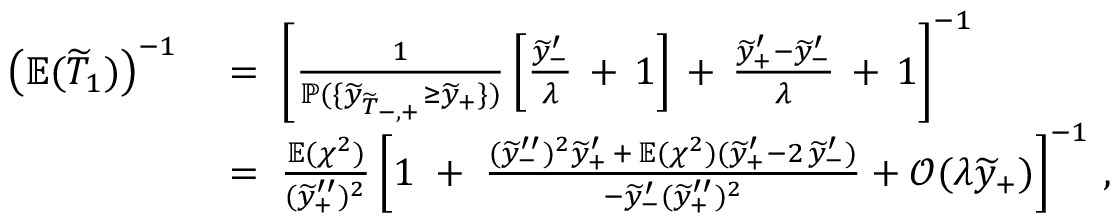<formula> <loc_0><loc_0><loc_500><loc_500>\begin{array} { r l } { \left ( \mathbb { E } ( \widetilde { T } _ { 1 } ) \right ) ^ { - 1 } } & { \, = \, \left [ \frac { 1 } { \mathbb { P } ( \{ \widetilde { y } _ { \widetilde { T } _ { - , + } } \geq \widetilde { y } _ { + } \} ) } \left [ \frac { \widetilde { y } _ { - } ^ { \prime } } { \lambda } \, + \, 1 \right ] \, + \, \frac { \widetilde { y } _ { + } ^ { \prime } - \widetilde { y } _ { - } ^ { \prime } } { \lambda } \, + \, 1 \right ] ^ { - 1 } } \\ & { \, = \, \frac { \mathbb { E } ( \chi ^ { 2 } ) } { ( \widetilde { y } _ { + } ^ { \prime \prime } ) ^ { 2 } } \left [ 1 \, + \, \frac { ( \widetilde { y } _ { - } ^ { \prime \prime } ) ^ { 2 } \widetilde { y } _ { + } ^ { \prime } \, + \, \mathbb { E } ( \chi ^ { 2 } ) ( \widetilde { y } _ { + } ^ { \prime } - 2 \, \widetilde { y } _ { - } ^ { \prime } ) } { - \widetilde { y } _ { - } ^ { \prime } ( \widetilde { y } _ { + } ^ { \prime \prime } ) ^ { 2 } } + \mathcal { O } ( \lambda \widetilde { y } _ { + } ) \right ] ^ { - 1 } \, , } \end{array}</formula> 